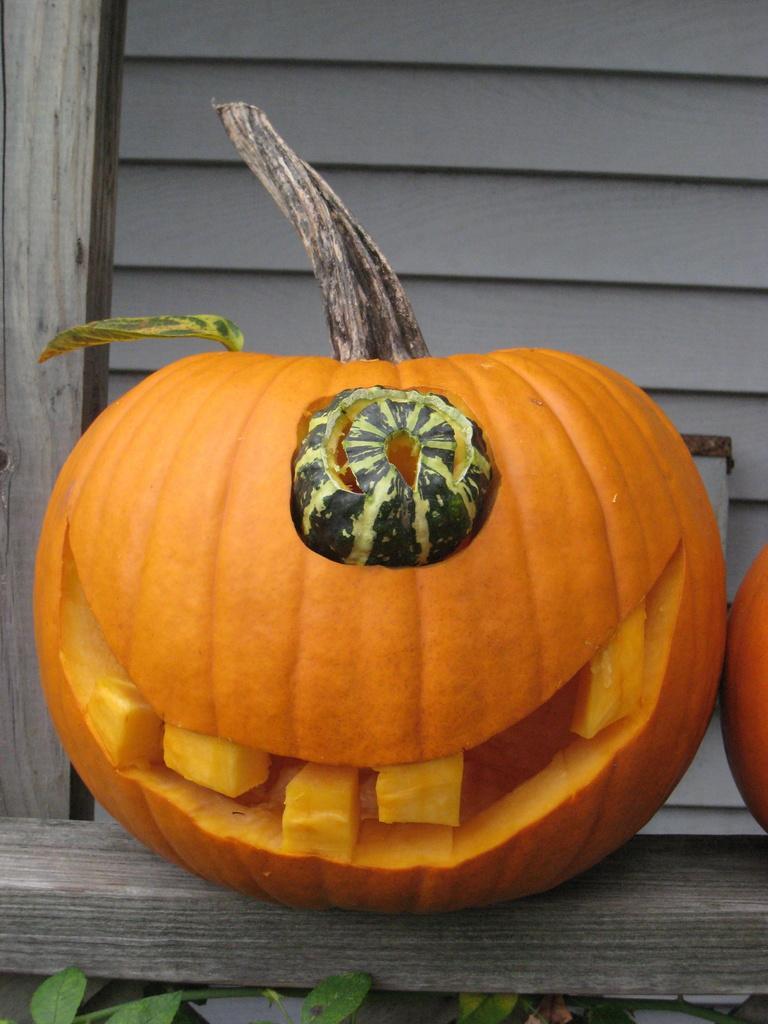In one or two sentences, can you explain what this image depicts? In this image in the center there is one pumpkin which is carved, and in the background there is a wooden stick. And at the bottom there is a wooden stick and some plants, and on the right side of the image there is another pumpkin. 